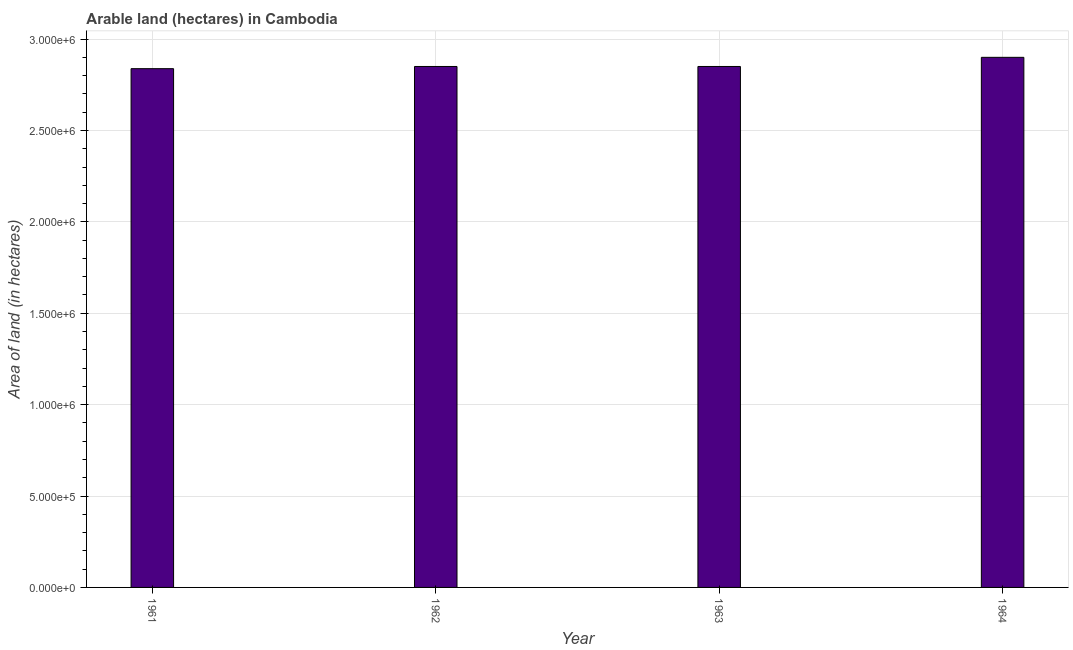Does the graph contain grids?
Your response must be concise. Yes. What is the title of the graph?
Offer a very short reply. Arable land (hectares) in Cambodia. What is the label or title of the X-axis?
Provide a short and direct response. Year. What is the label or title of the Y-axis?
Offer a terse response. Area of land (in hectares). What is the area of land in 1961?
Make the answer very short. 2.84e+06. Across all years, what is the maximum area of land?
Offer a terse response. 2.90e+06. Across all years, what is the minimum area of land?
Give a very brief answer. 2.84e+06. In which year was the area of land maximum?
Offer a terse response. 1964. What is the sum of the area of land?
Ensure brevity in your answer.  1.14e+07. What is the average area of land per year?
Ensure brevity in your answer.  2.86e+06. What is the median area of land?
Ensure brevity in your answer.  2.85e+06. Do a majority of the years between 1961 and 1963 (inclusive) have area of land greater than 400000 hectares?
Your answer should be compact. Yes. What is the difference between the highest and the lowest area of land?
Ensure brevity in your answer.  6.20e+04. How many bars are there?
Your answer should be compact. 4. What is the difference between two consecutive major ticks on the Y-axis?
Offer a very short reply. 5.00e+05. What is the Area of land (in hectares) of 1961?
Make the answer very short. 2.84e+06. What is the Area of land (in hectares) of 1962?
Offer a very short reply. 2.85e+06. What is the Area of land (in hectares) of 1963?
Your response must be concise. 2.85e+06. What is the Area of land (in hectares) of 1964?
Make the answer very short. 2.90e+06. What is the difference between the Area of land (in hectares) in 1961 and 1962?
Your response must be concise. -1.20e+04. What is the difference between the Area of land (in hectares) in 1961 and 1963?
Give a very brief answer. -1.20e+04. What is the difference between the Area of land (in hectares) in 1961 and 1964?
Your answer should be very brief. -6.20e+04. What is the ratio of the Area of land (in hectares) in 1962 to that in 1964?
Provide a succinct answer. 0.98. 